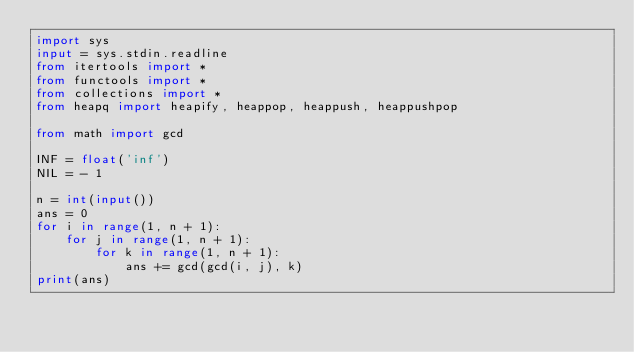<code> <loc_0><loc_0><loc_500><loc_500><_Python_>import sys
input = sys.stdin.readline
from itertools import *
from functools import *
from collections import *
from heapq import heapify, heappop, heappush, heappushpop

from math import gcd
    
INF = float('inf')
NIL = - 1

n = int(input())
ans = 0
for i in range(1, n + 1):
    for j in range(1, n + 1):
        for k in range(1, n + 1):
            ans += gcd(gcd(i, j), k)
print(ans)


</code> 